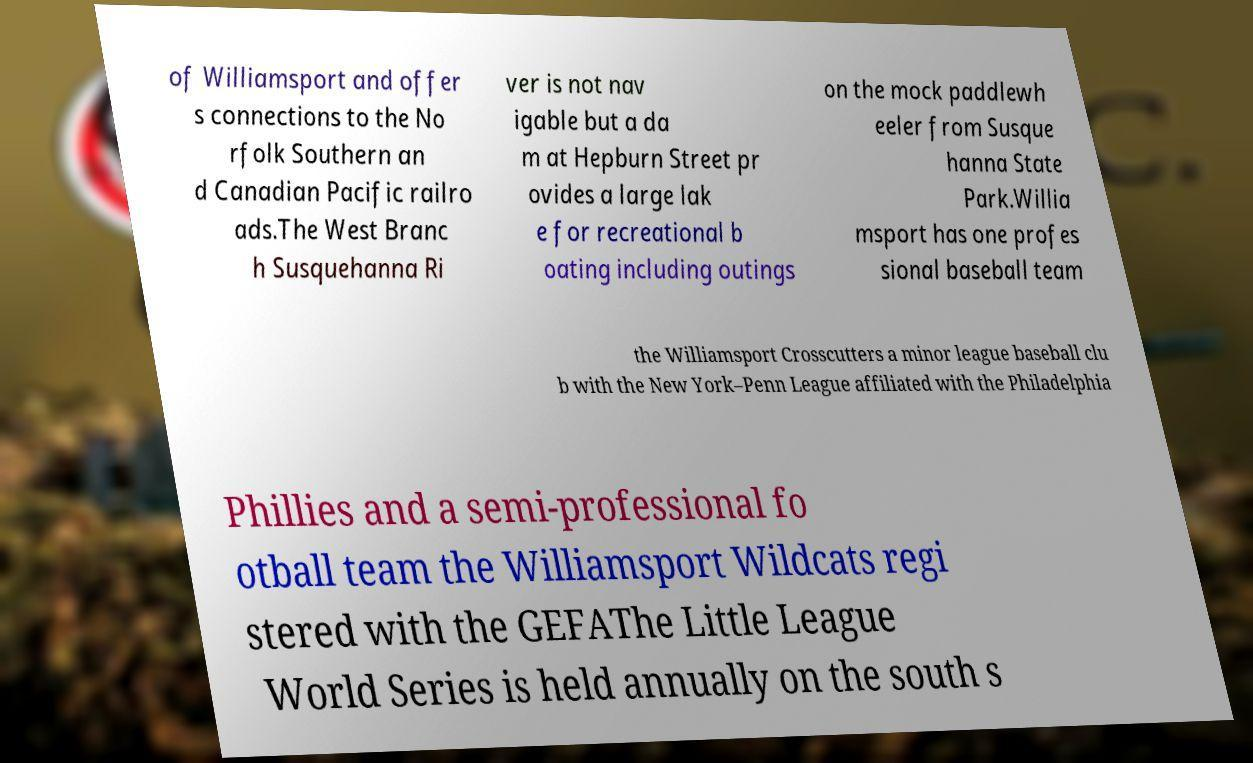I need the written content from this picture converted into text. Can you do that? of Williamsport and offer s connections to the No rfolk Southern an d Canadian Pacific railro ads.The West Branc h Susquehanna Ri ver is not nav igable but a da m at Hepburn Street pr ovides a large lak e for recreational b oating including outings on the mock paddlewh eeler from Susque hanna State Park.Willia msport has one profes sional baseball team the Williamsport Crosscutters a minor league baseball clu b with the New York–Penn League affiliated with the Philadelphia Phillies and a semi-professional fo otball team the Williamsport Wildcats regi stered with the GEFAThe Little League World Series is held annually on the south s 